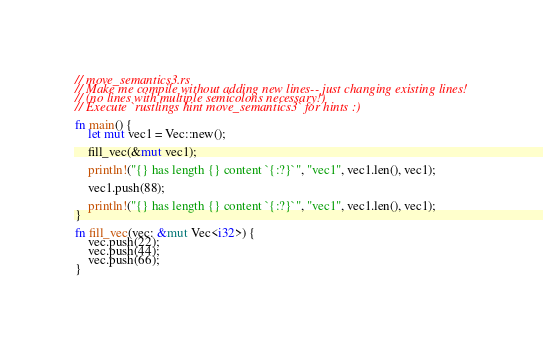Convert code to text. <code><loc_0><loc_0><loc_500><loc_500><_Rust_>// move_semantics3.rs
// Make me compile without adding new lines-- just changing existing lines!
// (no lines with multiple semicolons necessary!)
// Execute `rustlings hint move_semantics3` for hints :)

fn main() {
    let mut vec1 = Vec::new();

    fill_vec(&mut vec1);

    println!("{} has length {} content `{:?}`", "vec1", vec1.len(), vec1);

    vec1.push(88);

    println!("{} has length {} content `{:?}`", "vec1", vec1.len(), vec1);
}

fn fill_vec(vec: &mut Vec<i32>) {
    vec.push(22);
    vec.push(44);
    vec.push(66);
}
</code> 